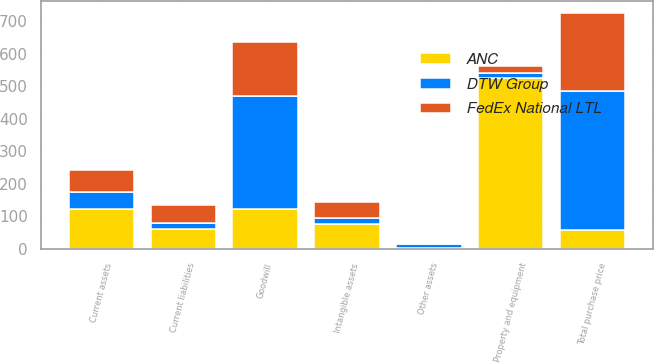<chart> <loc_0><loc_0><loc_500><loc_500><stacked_bar_chart><ecel><fcel>Current assets<fcel>Property and equipment<fcel>Intangible assets<fcel>Goodwill<fcel>Other assets<fcel>Current liabilities<fcel>Total purchase price<nl><fcel>ANC<fcel>121<fcel>525<fcel>77<fcel>121<fcel>3<fcel>60<fcel>58<nl><fcel>FedEx National LTL<fcel>68<fcel>20<fcel>49<fcel>168<fcel>2<fcel>56<fcel>241<nl><fcel>DTW Group<fcel>54<fcel>16<fcel>17<fcel>348<fcel>10<fcel>18<fcel>427<nl></chart> 